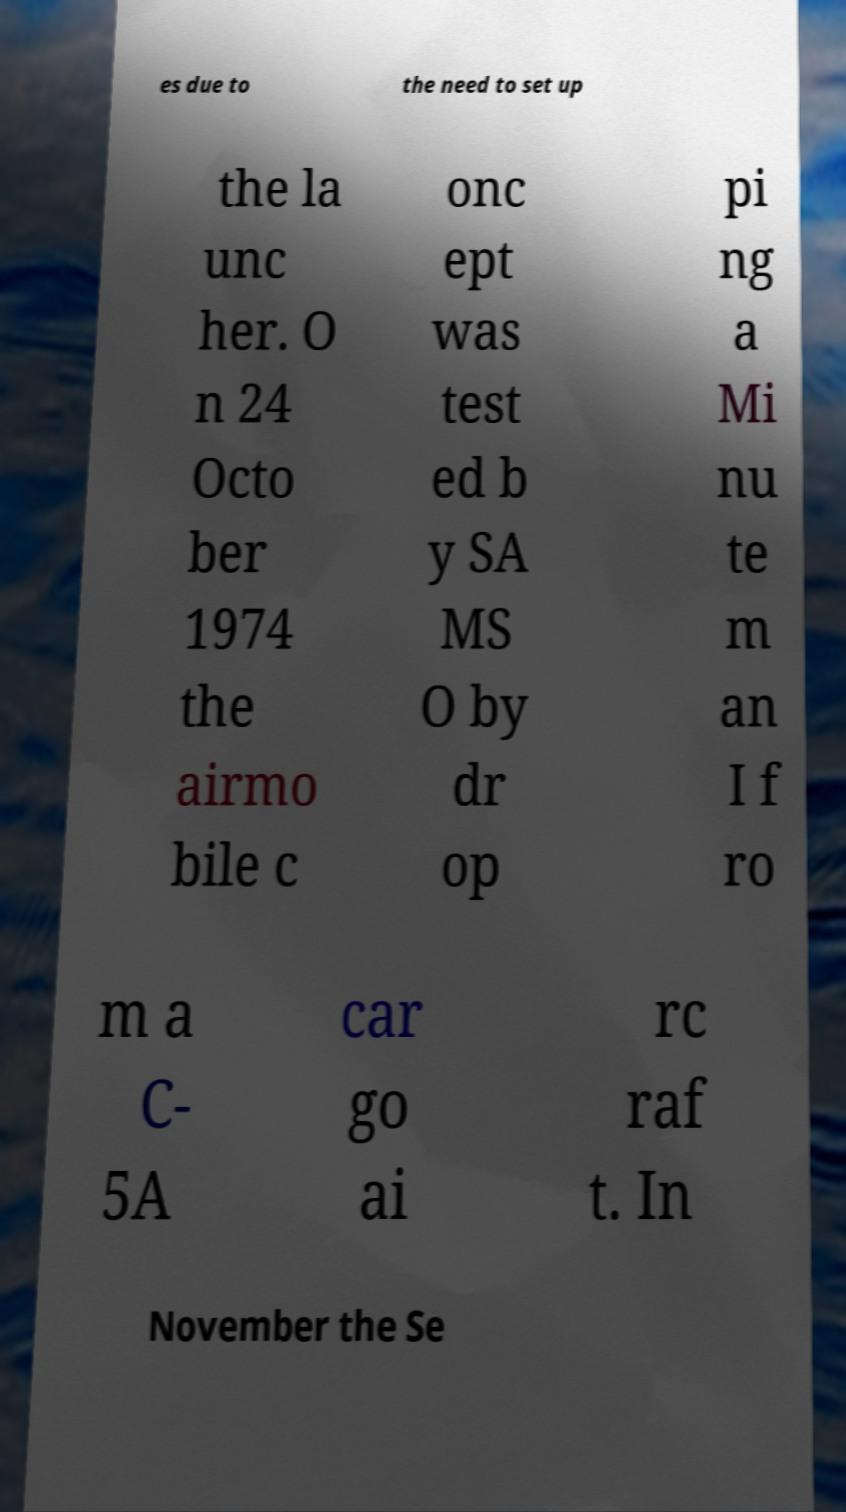Could you extract and type out the text from this image? es due to the need to set up the la unc her. O n 24 Octo ber 1974 the airmo bile c onc ept was test ed b y SA MS O by dr op pi ng a Mi nu te m an I f ro m a C- 5A car go ai rc raf t. In November the Se 